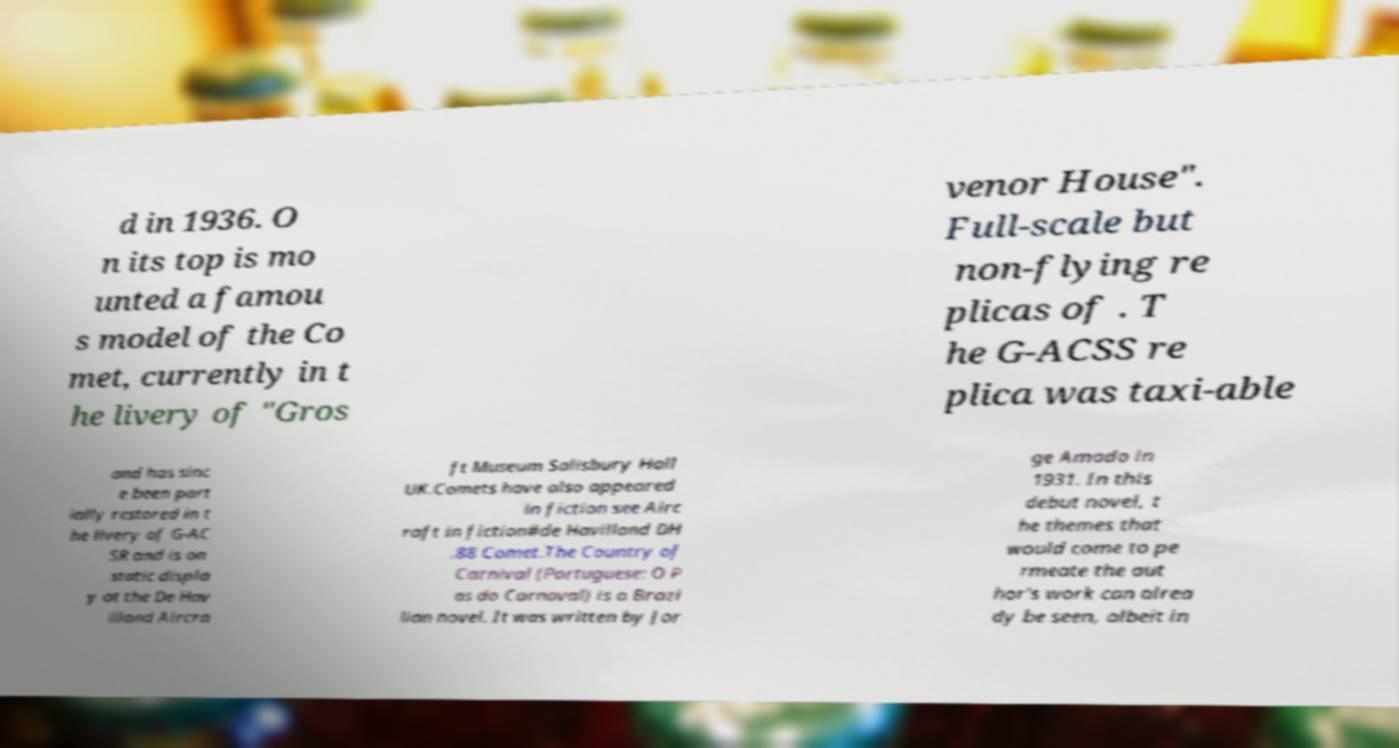Please identify and transcribe the text found in this image. d in 1936. O n its top is mo unted a famou s model of the Co met, currently in t he livery of "Gros venor House". Full-scale but non-flying re plicas of . T he G-ACSS re plica was taxi-able and has sinc e been part ially restored in t he livery of G-AC SR and is on static displa y at the De Hav illand Aircra ft Museum Salisbury Hall UK.Comets have also appeared in fiction see Airc raft in fiction#de Havilland DH .88 Comet.The Country of Carnival (Portuguese: O P as do Carnaval) is a Brazi lian novel. It was written by Jor ge Amado in 1931. In this debut novel, t he themes that would come to pe rmeate the aut hor's work can alrea dy be seen, albeit in 